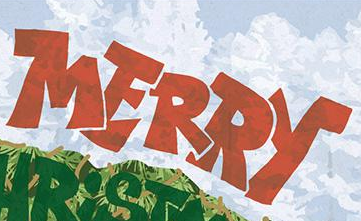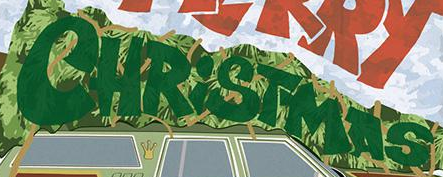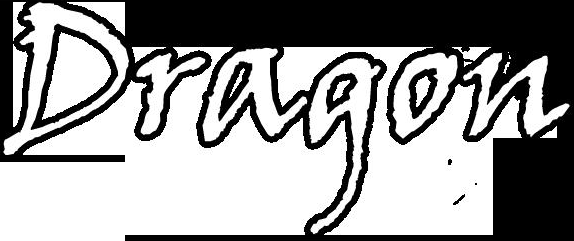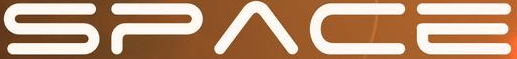What text appears in these images from left to right, separated by a semicolon? MERRY; CHRiSTMAS; Dragon; SPACE 